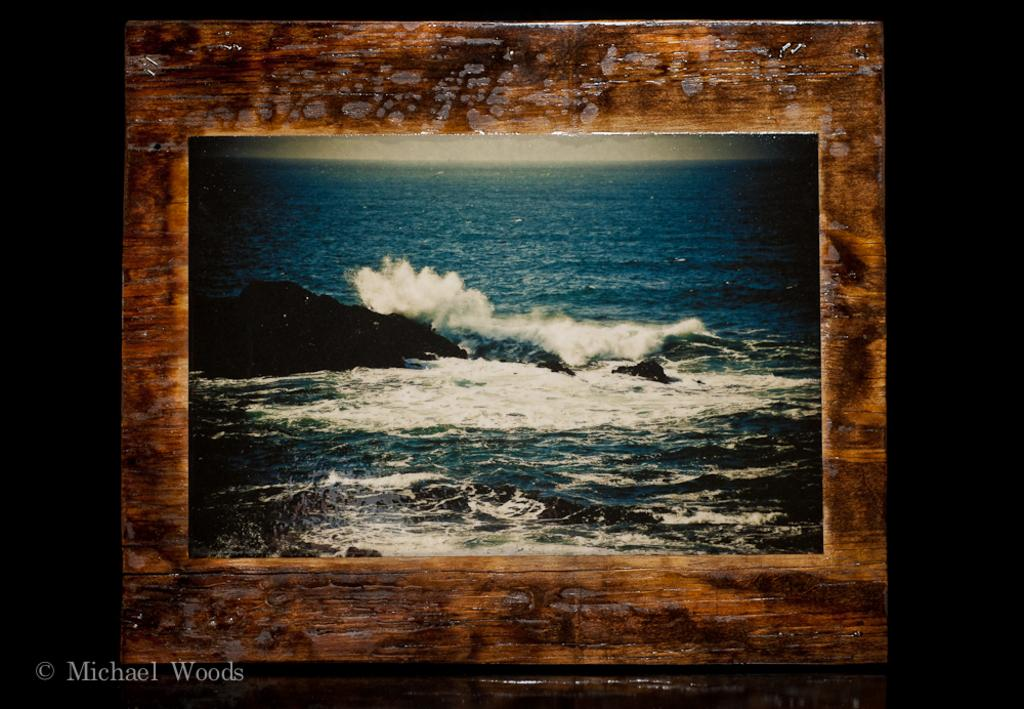What object is present in the image that typically holds a photograph? There is a photo frame in the image. What is depicted within the photo frame? The photo frame contains a depiction of waves in the water. What type of water is represented in the image? The water represents an ocean. Is there any land feature visible in the water? Yes, there is a rock in the water. How does the man in the image attempt to turn the tide? There is no man present in the image; it features a photo frame with a depiction of waves in the water. 